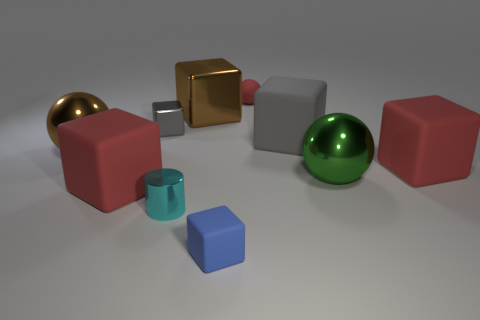Does the gray matte object have the same size as the brown cube?
Offer a very short reply. Yes. What number of blue cubes are the same material as the cyan thing?
Provide a short and direct response. 0. What is the cyan cylinder made of?
Keep it short and to the point. Metal. Are there fewer large gray rubber things to the left of the big gray cube than tiny cubes that are to the right of the tiny cylinder?
Make the answer very short. Yes. There is a sphere that is the same color as the large metal block; what material is it?
Provide a succinct answer. Metal. There is a big red object that is on the right side of the small blue rubber thing; is its shape the same as the big rubber thing that is left of the tiny rubber block?
Offer a very short reply. Yes. There is a blue thing that is the same size as the cyan object; what material is it?
Offer a terse response. Rubber. Are the large red object that is to the right of the small red rubber sphere and the block in front of the cyan object made of the same material?
Ensure brevity in your answer.  Yes. What is the shape of the red object that is the same size as the cylinder?
Your answer should be very brief. Sphere. What number of other objects are there of the same color as the small ball?
Keep it short and to the point. 2. 